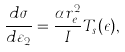Convert formula to latex. <formula><loc_0><loc_0><loc_500><loc_500>\frac { d \sigma } { d \varepsilon _ { 2 } } = \frac { \alpha r _ { e } ^ { 2 } } { I } T _ { s } ( \epsilon ) ,</formula> 